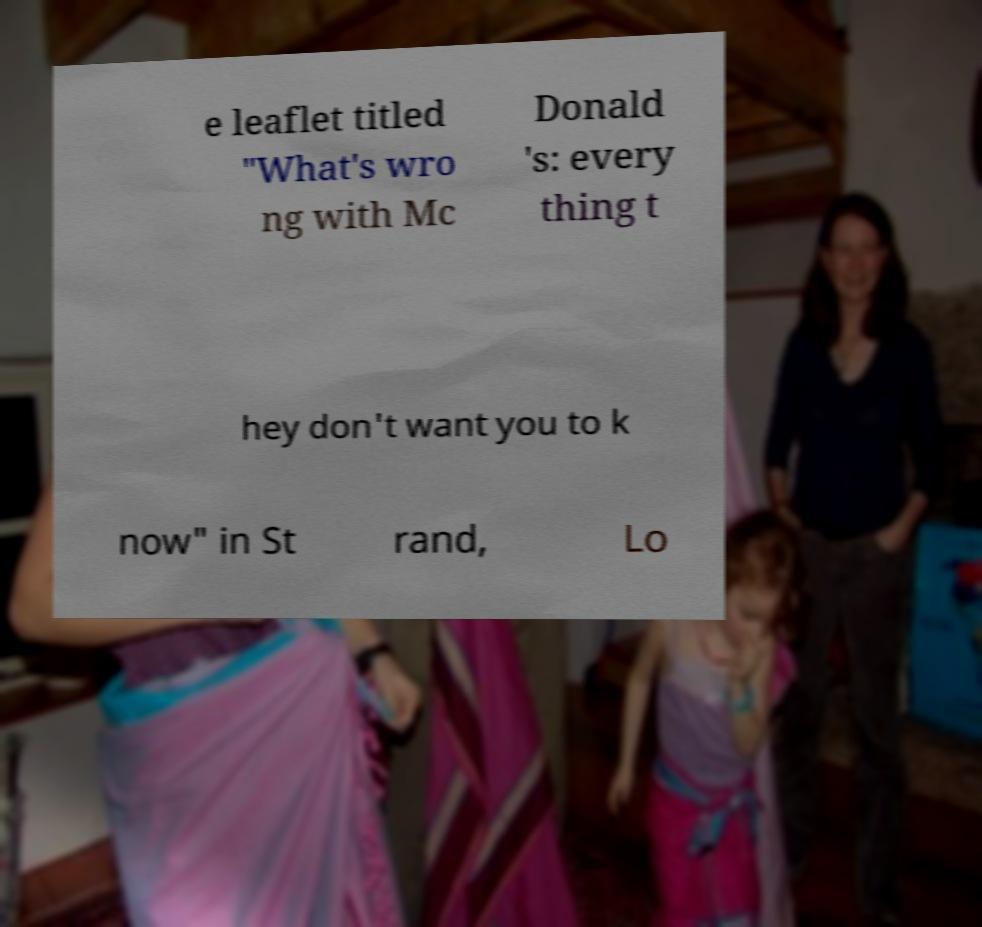For documentation purposes, I need the text within this image transcribed. Could you provide that? e leaflet titled "What's wro ng with Mc Donald 's: every thing t hey don't want you to k now" in St rand, Lo 